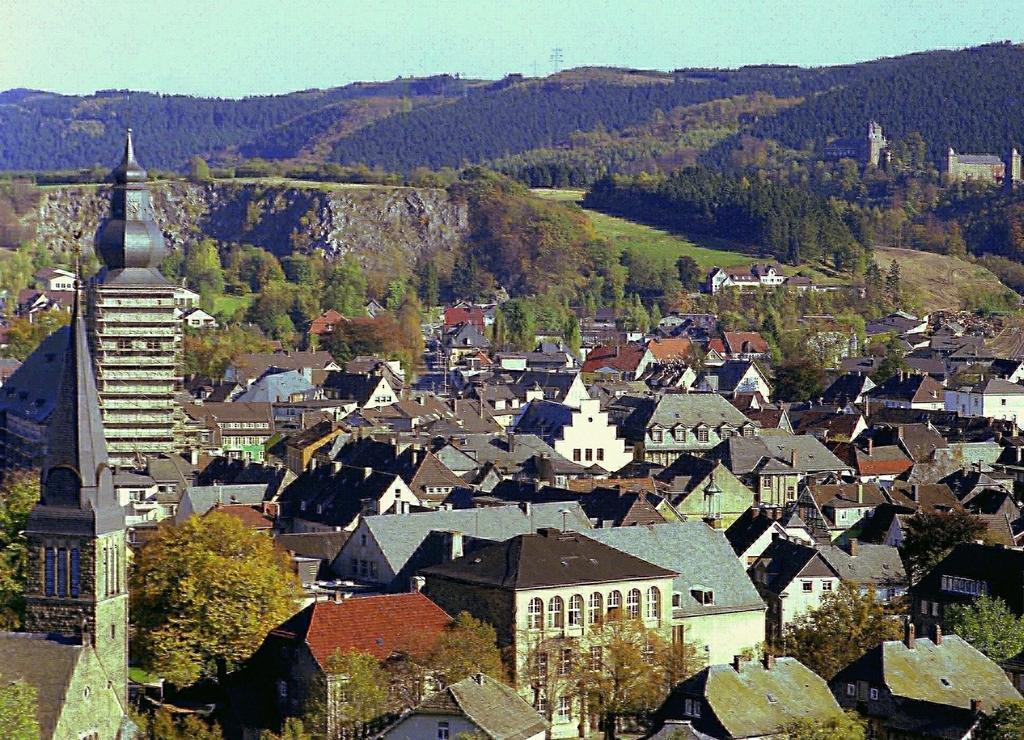Please provide a concise description of this image. In this image I can see number of trees and number of buildings in the front and in the background. I can also see the sky in the background. 